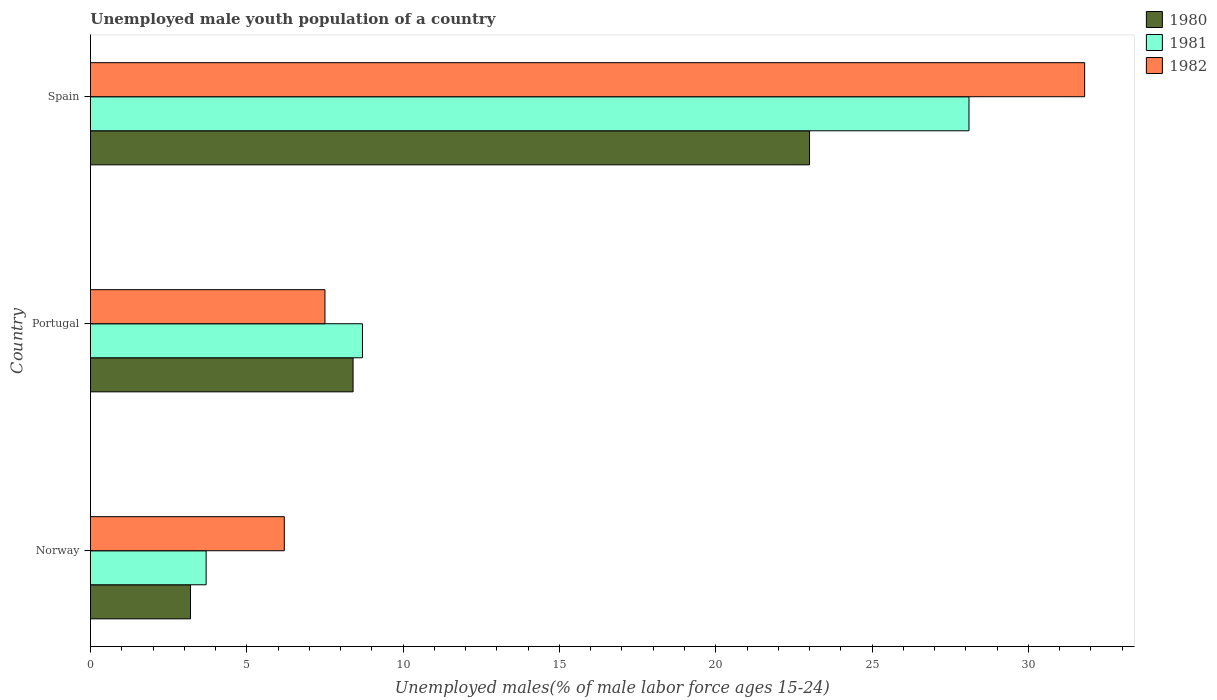How many groups of bars are there?
Your answer should be compact. 3. Are the number of bars per tick equal to the number of legend labels?
Give a very brief answer. Yes. Are the number of bars on each tick of the Y-axis equal?
Give a very brief answer. Yes. How many bars are there on the 3rd tick from the top?
Offer a very short reply. 3. How many bars are there on the 1st tick from the bottom?
Keep it short and to the point. 3. What is the label of the 2nd group of bars from the top?
Provide a short and direct response. Portugal. Across all countries, what is the maximum percentage of unemployed male youth population in 1980?
Keep it short and to the point. 23. Across all countries, what is the minimum percentage of unemployed male youth population in 1981?
Your answer should be compact. 3.7. What is the total percentage of unemployed male youth population in 1980 in the graph?
Keep it short and to the point. 34.6. What is the difference between the percentage of unemployed male youth population in 1981 in Norway and that in Spain?
Provide a succinct answer. -24.4. What is the difference between the percentage of unemployed male youth population in 1980 in Spain and the percentage of unemployed male youth population in 1981 in Norway?
Provide a succinct answer. 19.3. What is the average percentage of unemployed male youth population in 1980 per country?
Offer a very short reply. 11.53. What is the difference between the percentage of unemployed male youth population in 1982 and percentage of unemployed male youth population in 1981 in Spain?
Give a very brief answer. 3.7. In how many countries, is the percentage of unemployed male youth population in 1981 greater than 8 %?
Ensure brevity in your answer.  2. What is the ratio of the percentage of unemployed male youth population in 1980 in Portugal to that in Spain?
Your response must be concise. 0.37. Is the percentage of unemployed male youth population in 1980 in Norway less than that in Portugal?
Provide a succinct answer. Yes. What is the difference between the highest and the second highest percentage of unemployed male youth population in 1982?
Your answer should be compact. 24.3. What is the difference between the highest and the lowest percentage of unemployed male youth population in 1980?
Give a very brief answer. 19.8. Is the sum of the percentage of unemployed male youth population in 1981 in Portugal and Spain greater than the maximum percentage of unemployed male youth population in 1982 across all countries?
Make the answer very short. Yes. What does the 3rd bar from the bottom in Norway represents?
Your answer should be compact. 1982. Are all the bars in the graph horizontal?
Ensure brevity in your answer.  Yes. Does the graph contain grids?
Your answer should be very brief. No. Where does the legend appear in the graph?
Offer a terse response. Top right. What is the title of the graph?
Give a very brief answer. Unemployed male youth population of a country. Does "2008" appear as one of the legend labels in the graph?
Your answer should be compact. No. What is the label or title of the X-axis?
Provide a succinct answer. Unemployed males(% of male labor force ages 15-24). What is the Unemployed males(% of male labor force ages 15-24) in 1980 in Norway?
Your response must be concise. 3.2. What is the Unemployed males(% of male labor force ages 15-24) in 1981 in Norway?
Offer a terse response. 3.7. What is the Unemployed males(% of male labor force ages 15-24) in 1982 in Norway?
Your response must be concise. 6.2. What is the Unemployed males(% of male labor force ages 15-24) in 1980 in Portugal?
Offer a very short reply. 8.4. What is the Unemployed males(% of male labor force ages 15-24) in 1981 in Portugal?
Your answer should be compact. 8.7. What is the Unemployed males(% of male labor force ages 15-24) of 1980 in Spain?
Make the answer very short. 23. What is the Unemployed males(% of male labor force ages 15-24) in 1981 in Spain?
Provide a succinct answer. 28.1. What is the Unemployed males(% of male labor force ages 15-24) of 1982 in Spain?
Your answer should be very brief. 31.8. Across all countries, what is the maximum Unemployed males(% of male labor force ages 15-24) in 1980?
Ensure brevity in your answer.  23. Across all countries, what is the maximum Unemployed males(% of male labor force ages 15-24) in 1981?
Offer a terse response. 28.1. Across all countries, what is the maximum Unemployed males(% of male labor force ages 15-24) in 1982?
Your answer should be very brief. 31.8. Across all countries, what is the minimum Unemployed males(% of male labor force ages 15-24) of 1980?
Provide a succinct answer. 3.2. Across all countries, what is the minimum Unemployed males(% of male labor force ages 15-24) of 1981?
Keep it short and to the point. 3.7. Across all countries, what is the minimum Unemployed males(% of male labor force ages 15-24) in 1982?
Offer a terse response. 6.2. What is the total Unemployed males(% of male labor force ages 15-24) in 1980 in the graph?
Keep it short and to the point. 34.6. What is the total Unemployed males(% of male labor force ages 15-24) of 1981 in the graph?
Offer a terse response. 40.5. What is the total Unemployed males(% of male labor force ages 15-24) in 1982 in the graph?
Keep it short and to the point. 45.5. What is the difference between the Unemployed males(% of male labor force ages 15-24) in 1981 in Norway and that in Portugal?
Your answer should be very brief. -5. What is the difference between the Unemployed males(% of male labor force ages 15-24) in 1982 in Norway and that in Portugal?
Give a very brief answer. -1.3. What is the difference between the Unemployed males(% of male labor force ages 15-24) of 1980 in Norway and that in Spain?
Your answer should be compact. -19.8. What is the difference between the Unemployed males(% of male labor force ages 15-24) of 1981 in Norway and that in Spain?
Your answer should be compact. -24.4. What is the difference between the Unemployed males(% of male labor force ages 15-24) in 1982 in Norway and that in Spain?
Make the answer very short. -25.6. What is the difference between the Unemployed males(% of male labor force ages 15-24) of 1980 in Portugal and that in Spain?
Make the answer very short. -14.6. What is the difference between the Unemployed males(% of male labor force ages 15-24) of 1981 in Portugal and that in Spain?
Provide a succinct answer. -19.4. What is the difference between the Unemployed males(% of male labor force ages 15-24) in 1982 in Portugal and that in Spain?
Make the answer very short. -24.3. What is the difference between the Unemployed males(% of male labor force ages 15-24) of 1980 in Norway and the Unemployed males(% of male labor force ages 15-24) of 1982 in Portugal?
Offer a very short reply. -4.3. What is the difference between the Unemployed males(% of male labor force ages 15-24) in 1981 in Norway and the Unemployed males(% of male labor force ages 15-24) in 1982 in Portugal?
Make the answer very short. -3.8. What is the difference between the Unemployed males(% of male labor force ages 15-24) of 1980 in Norway and the Unemployed males(% of male labor force ages 15-24) of 1981 in Spain?
Give a very brief answer. -24.9. What is the difference between the Unemployed males(% of male labor force ages 15-24) of 1980 in Norway and the Unemployed males(% of male labor force ages 15-24) of 1982 in Spain?
Ensure brevity in your answer.  -28.6. What is the difference between the Unemployed males(% of male labor force ages 15-24) of 1981 in Norway and the Unemployed males(% of male labor force ages 15-24) of 1982 in Spain?
Provide a short and direct response. -28.1. What is the difference between the Unemployed males(% of male labor force ages 15-24) of 1980 in Portugal and the Unemployed males(% of male labor force ages 15-24) of 1981 in Spain?
Provide a succinct answer. -19.7. What is the difference between the Unemployed males(% of male labor force ages 15-24) of 1980 in Portugal and the Unemployed males(% of male labor force ages 15-24) of 1982 in Spain?
Offer a terse response. -23.4. What is the difference between the Unemployed males(% of male labor force ages 15-24) in 1981 in Portugal and the Unemployed males(% of male labor force ages 15-24) in 1982 in Spain?
Keep it short and to the point. -23.1. What is the average Unemployed males(% of male labor force ages 15-24) of 1980 per country?
Your answer should be compact. 11.53. What is the average Unemployed males(% of male labor force ages 15-24) of 1982 per country?
Ensure brevity in your answer.  15.17. What is the difference between the Unemployed males(% of male labor force ages 15-24) of 1980 and Unemployed males(% of male labor force ages 15-24) of 1981 in Norway?
Your response must be concise. -0.5. What is the difference between the Unemployed males(% of male labor force ages 15-24) in 1980 and Unemployed males(% of male labor force ages 15-24) in 1982 in Norway?
Make the answer very short. -3. What is the difference between the Unemployed males(% of male labor force ages 15-24) in 1980 and Unemployed males(% of male labor force ages 15-24) in 1981 in Portugal?
Your answer should be very brief. -0.3. What is the difference between the Unemployed males(% of male labor force ages 15-24) in 1980 and Unemployed males(% of male labor force ages 15-24) in 1982 in Spain?
Keep it short and to the point. -8.8. What is the difference between the Unemployed males(% of male labor force ages 15-24) of 1981 and Unemployed males(% of male labor force ages 15-24) of 1982 in Spain?
Provide a succinct answer. -3.7. What is the ratio of the Unemployed males(% of male labor force ages 15-24) of 1980 in Norway to that in Portugal?
Your answer should be compact. 0.38. What is the ratio of the Unemployed males(% of male labor force ages 15-24) of 1981 in Norway to that in Portugal?
Your answer should be very brief. 0.43. What is the ratio of the Unemployed males(% of male labor force ages 15-24) of 1982 in Norway to that in Portugal?
Your answer should be compact. 0.83. What is the ratio of the Unemployed males(% of male labor force ages 15-24) in 1980 in Norway to that in Spain?
Provide a succinct answer. 0.14. What is the ratio of the Unemployed males(% of male labor force ages 15-24) in 1981 in Norway to that in Spain?
Provide a succinct answer. 0.13. What is the ratio of the Unemployed males(% of male labor force ages 15-24) of 1982 in Norway to that in Spain?
Your answer should be compact. 0.2. What is the ratio of the Unemployed males(% of male labor force ages 15-24) of 1980 in Portugal to that in Spain?
Offer a very short reply. 0.37. What is the ratio of the Unemployed males(% of male labor force ages 15-24) of 1981 in Portugal to that in Spain?
Offer a terse response. 0.31. What is the ratio of the Unemployed males(% of male labor force ages 15-24) of 1982 in Portugal to that in Spain?
Provide a short and direct response. 0.24. What is the difference between the highest and the second highest Unemployed males(% of male labor force ages 15-24) in 1980?
Your answer should be compact. 14.6. What is the difference between the highest and the second highest Unemployed males(% of male labor force ages 15-24) of 1981?
Ensure brevity in your answer.  19.4. What is the difference between the highest and the second highest Unemployed males(% of male labor force ages 15-24) in 1982?
Offer a terse response. 24.3. What is the difference between the highest and the lowest Unemployed males(% of male labor force ages 15-24) in 1980?
Offer a terse response. 19.8. What is the difference between the highest and the lowest Unemployed males(% of male labor force ages 15-24) of 1981?
Offer a very short reply. 24.4. What is the difference between the highest and the lowest Unemployed males(% of male labor force ages 15-24) in 1982?
Give a very brief answer. 25.6. 